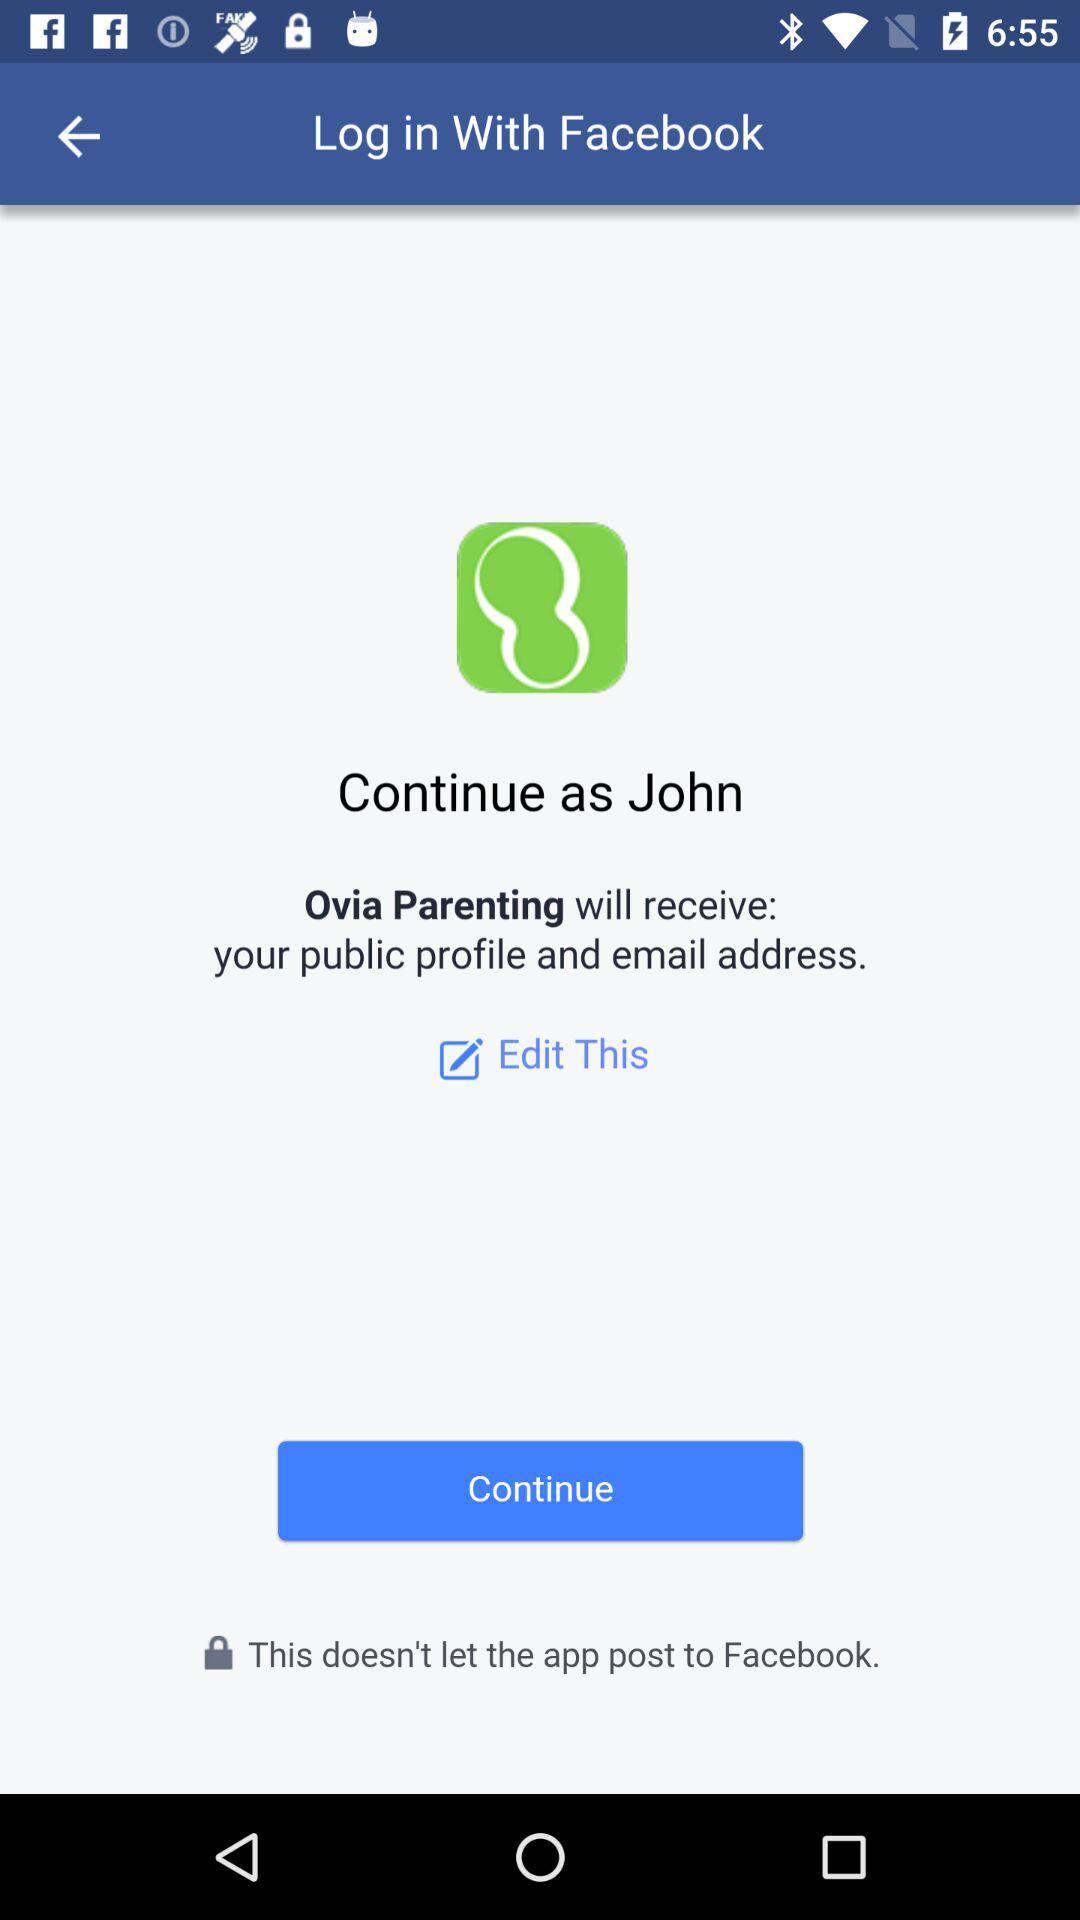What application is asking for permission? The application asking for permission is "Ovia Parenting". 